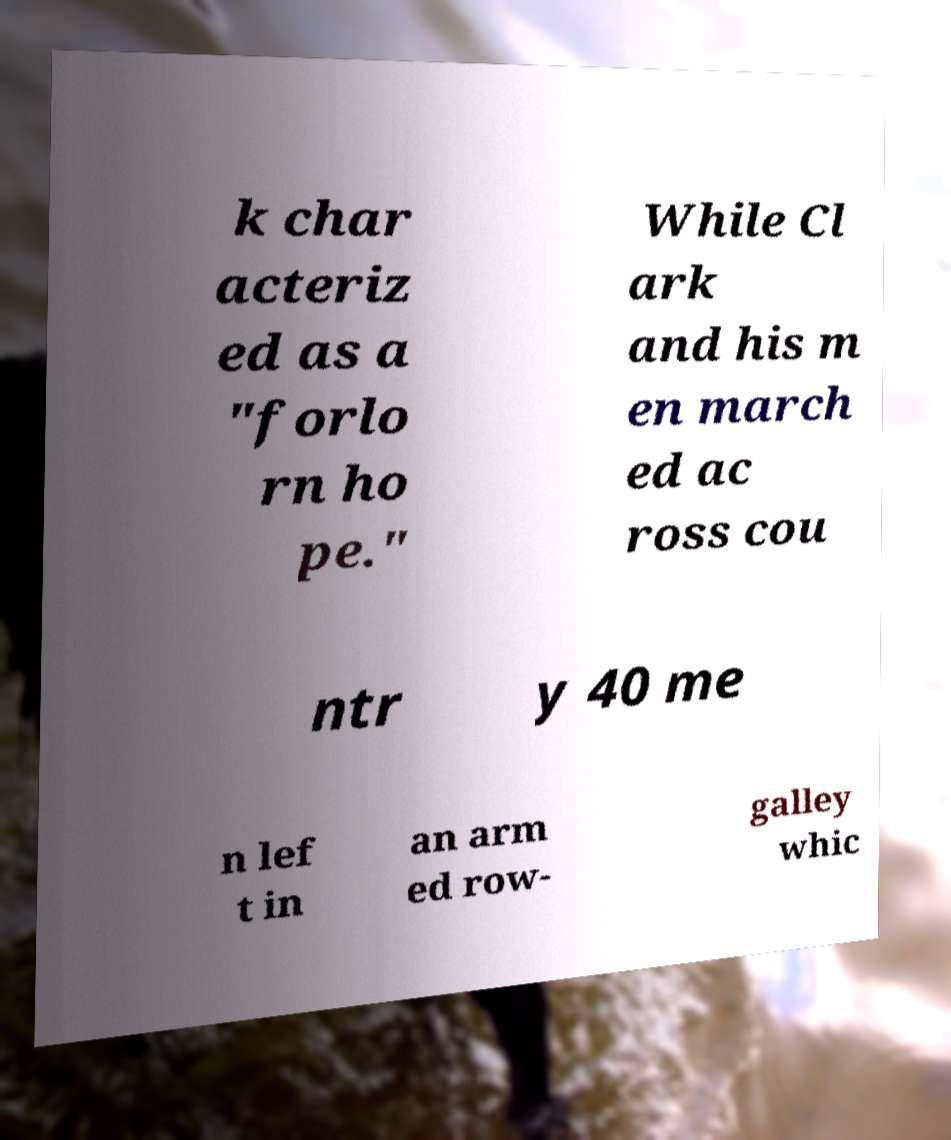Please identify and transcribe the text found in this image. k char acteriz ed as a "forlo rn ho pe." While Cl ark and his m en march ed ac ross cou ntr y 40 me n lef t in an arm ed row- galley whic 